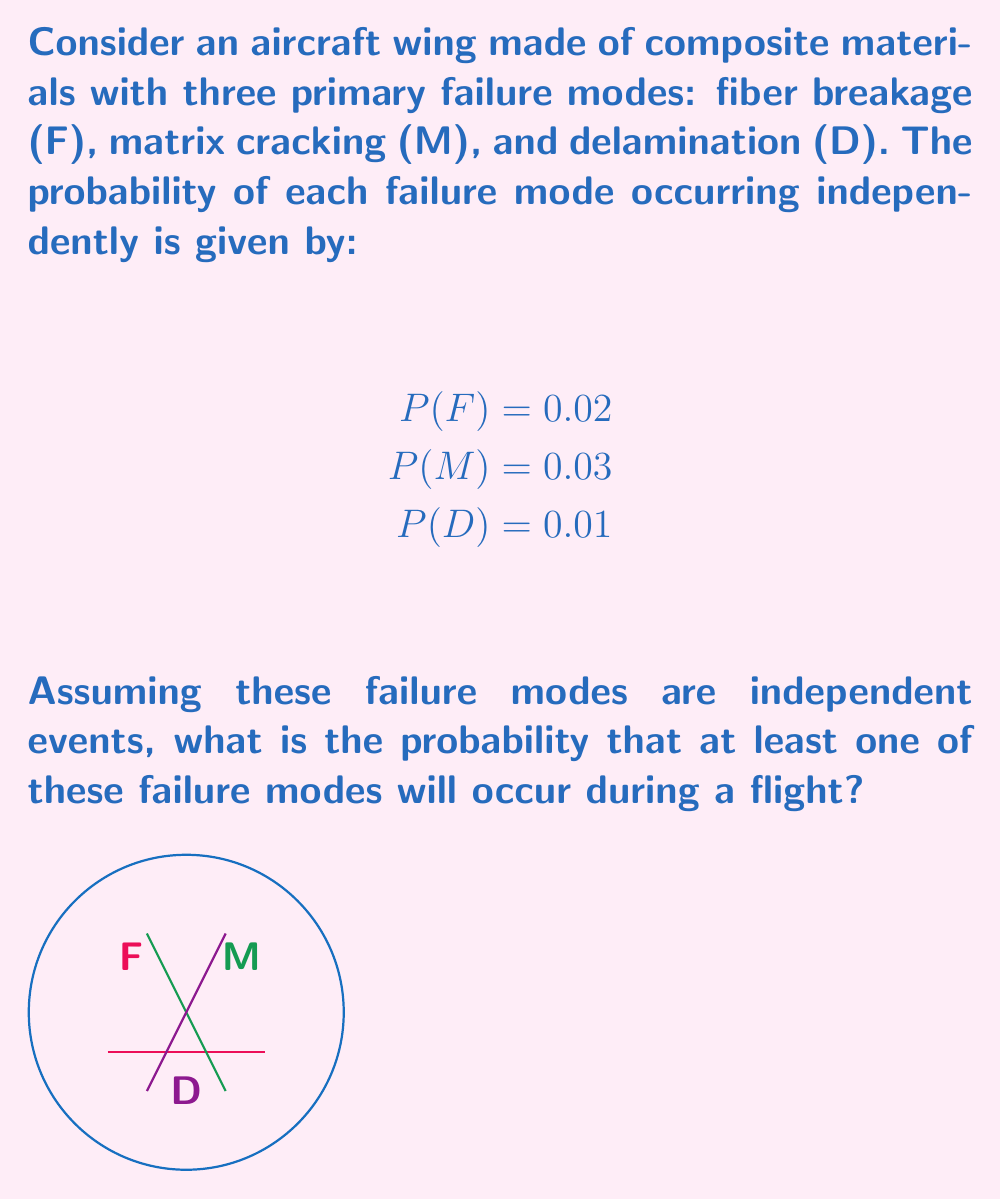Help me with this question. To solve this problem, we'll use the concept of probability of the union of independent events.

Step 1: The probability that at least one failure mode occurs is the complement of the probability that none of the failure modes occur.

Step 2: The probability that none of the failure modes occur is the product of the probabilities that each individual failure mode does not occur:

$P(\text{no failure}) = (1-P(F)) \times (1-P(M)) \times (1-P(D))$

Step 3: Substitute the given probabilities:

$P(\text{no failure}) = (1-0.02) \times (1-0.03) \times (1-0.01)$

Step 4: Calculate:

$P(\text{no failure}) = 0.98 \times 0.97 \times 0.99 = 0.941094$

Step 5: The probability of at least one failure mode occurring is the complement of this:

$P(\text{at least one failure}) = 1 - P(\text{no failure})$
$= 1 - 0.941094 = 0.058906$

Step 6: Convert to a percentage:

$0.058906 \times 100\% = 5.8906\%$
Answer: 5.8906% 